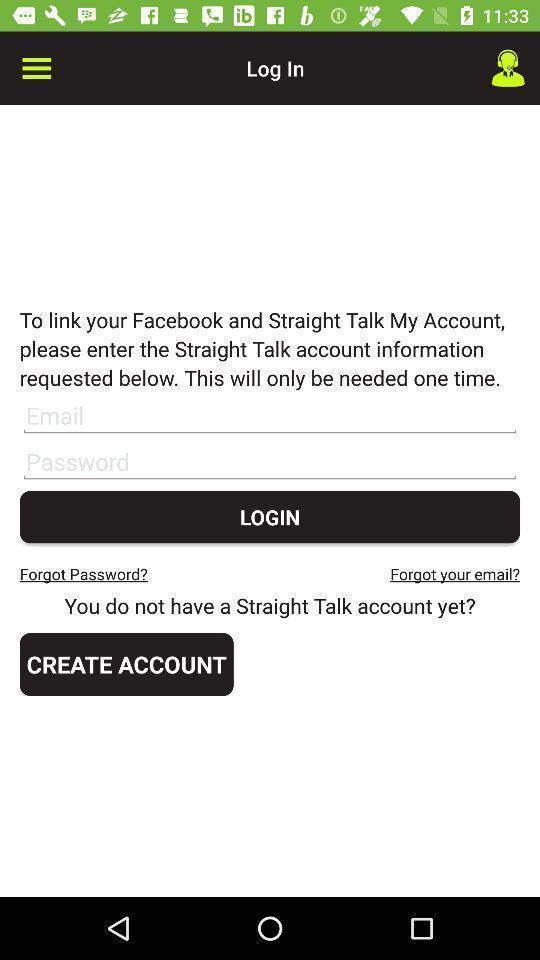Provide a description of this screenshot. Login page. 